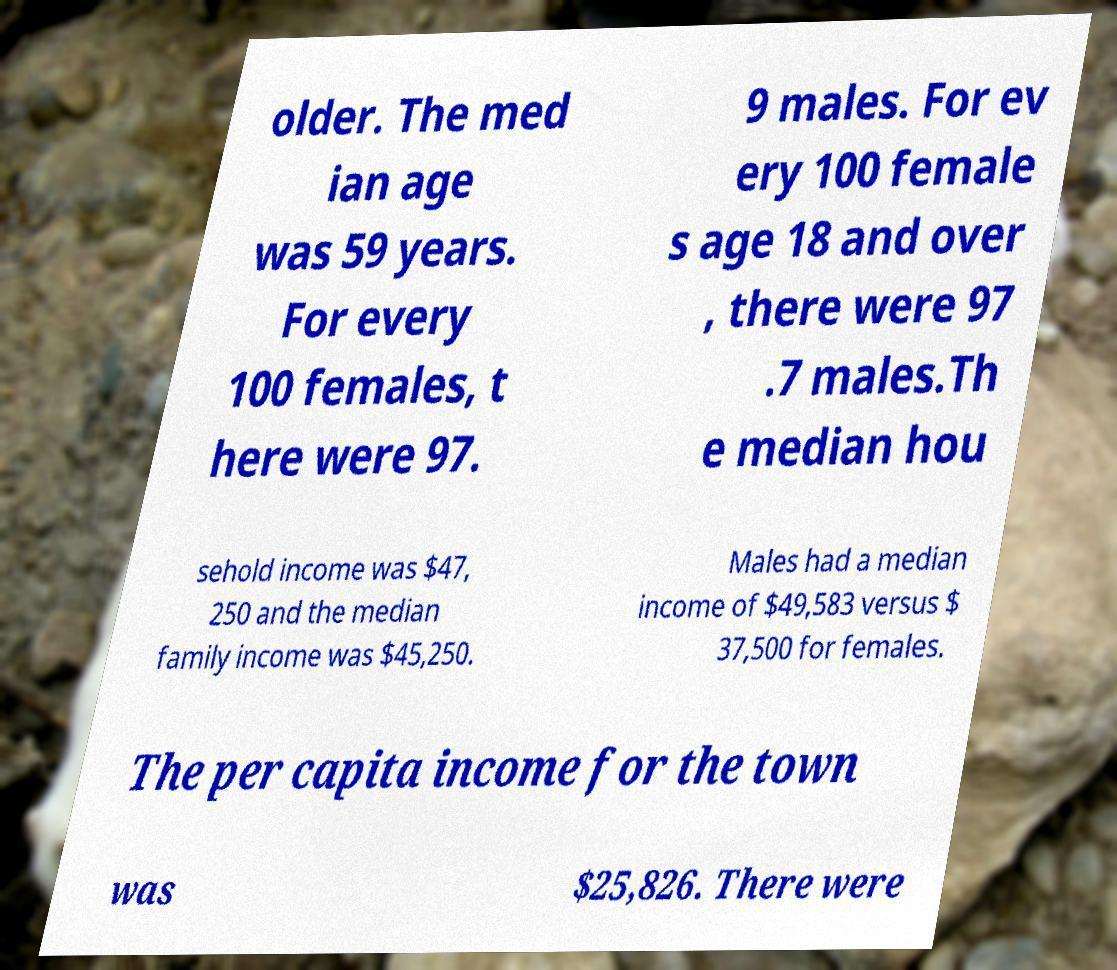For documentation purposes, I need the text within this image transcribed. Could you provide that? older. The med ian age was 59 years. For every 100 females, t here were 97. 9 males. For ev ery 100 female s age 18 and over , there were 97 .7 males.Th e median hou sehold income was $47, 250 and the median family income was $45,250. Males had a median income of $49,583 versus $ 37,500 for females. The per capita income for the town was $25,826. There were 